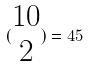Convert formula to latex. <formula><loc_0><loc_0><loc_500><loc_500>( \begin{matrix} 1 0 \\ 2 \end{matrix} ) = 4 5</formula> 